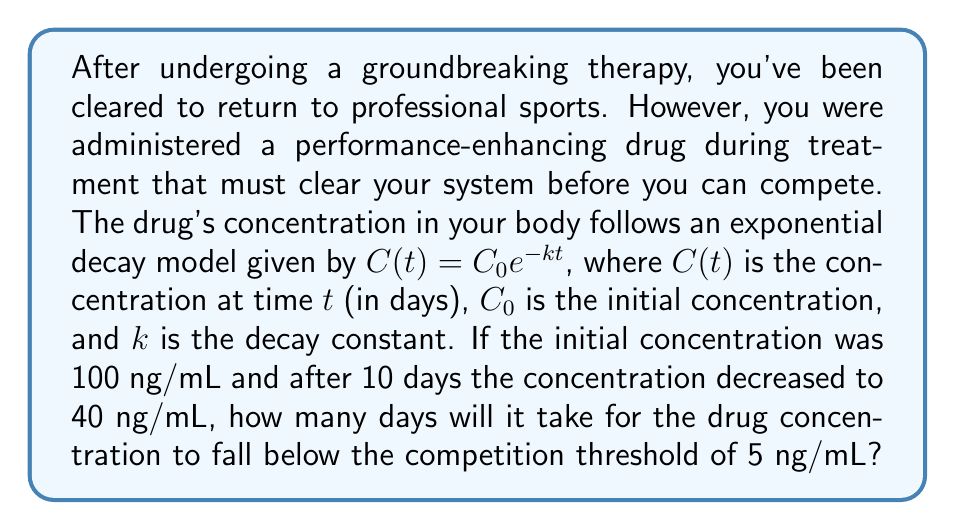Could you help me with this problem? To solve this problem, we'll follow these steps:

1) First, we need to find the decay constant $k$ using the given information:
   $C(10) = 40$ ng/mL, $C_0 = 100$ ng/mL, and $t = 10$ days

   Substituting into the exponential decay equation:
   $$40 = 100 e^{-10k}$$

2) Solving for $k$:
   $$\frac{40}{100} = e^{-10k}$$
   $$0.4 = e^{-10k}$$
   $$\ln(0.4) = -10k$$
   $$k = -\frac{\ln(0.4)}{10} \approx 0.0916$$

3) Now that we have $k$, we can use the original equation to find $t$ when $C(t) = 5$ ng/mL:
   $$5 = 100 e^{-0.0916t}$$

4) Solving for $t$:
   $$\frac{5}{100} = e^{-0.0916t}$$
   $$0.05 = e^{-0.0916t}$$
   $$\ln(0.05) = -0.0916t$$
   $$t = -\frac{\ln(0.05)}{0.0916} \approx 32.61$$

5) Since we can't have a fractional day in this context, we round up to the next whole day.
Answer: 33 days 